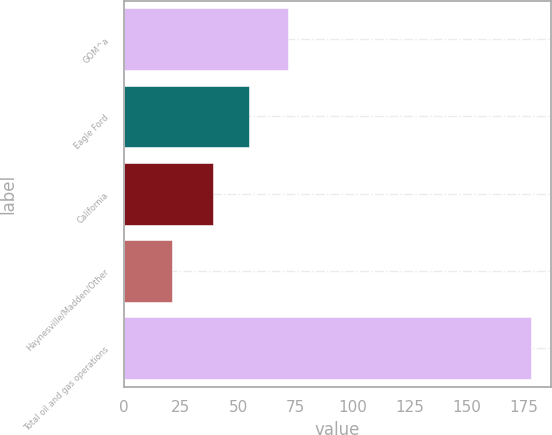Convert chart to OTSL. <chart><loc_0><loc_0><loc_500><loc_500><bar_chart><fcel>GOM^a<fcel>Eagle Ford<fcel>California<fcel>Haynesville/Madden/Other<fcel>Total oil and gas operations<nl><fcel>72<fcel>54.7<fcel>39<fcel>21<fcel>178<nl></chart> 